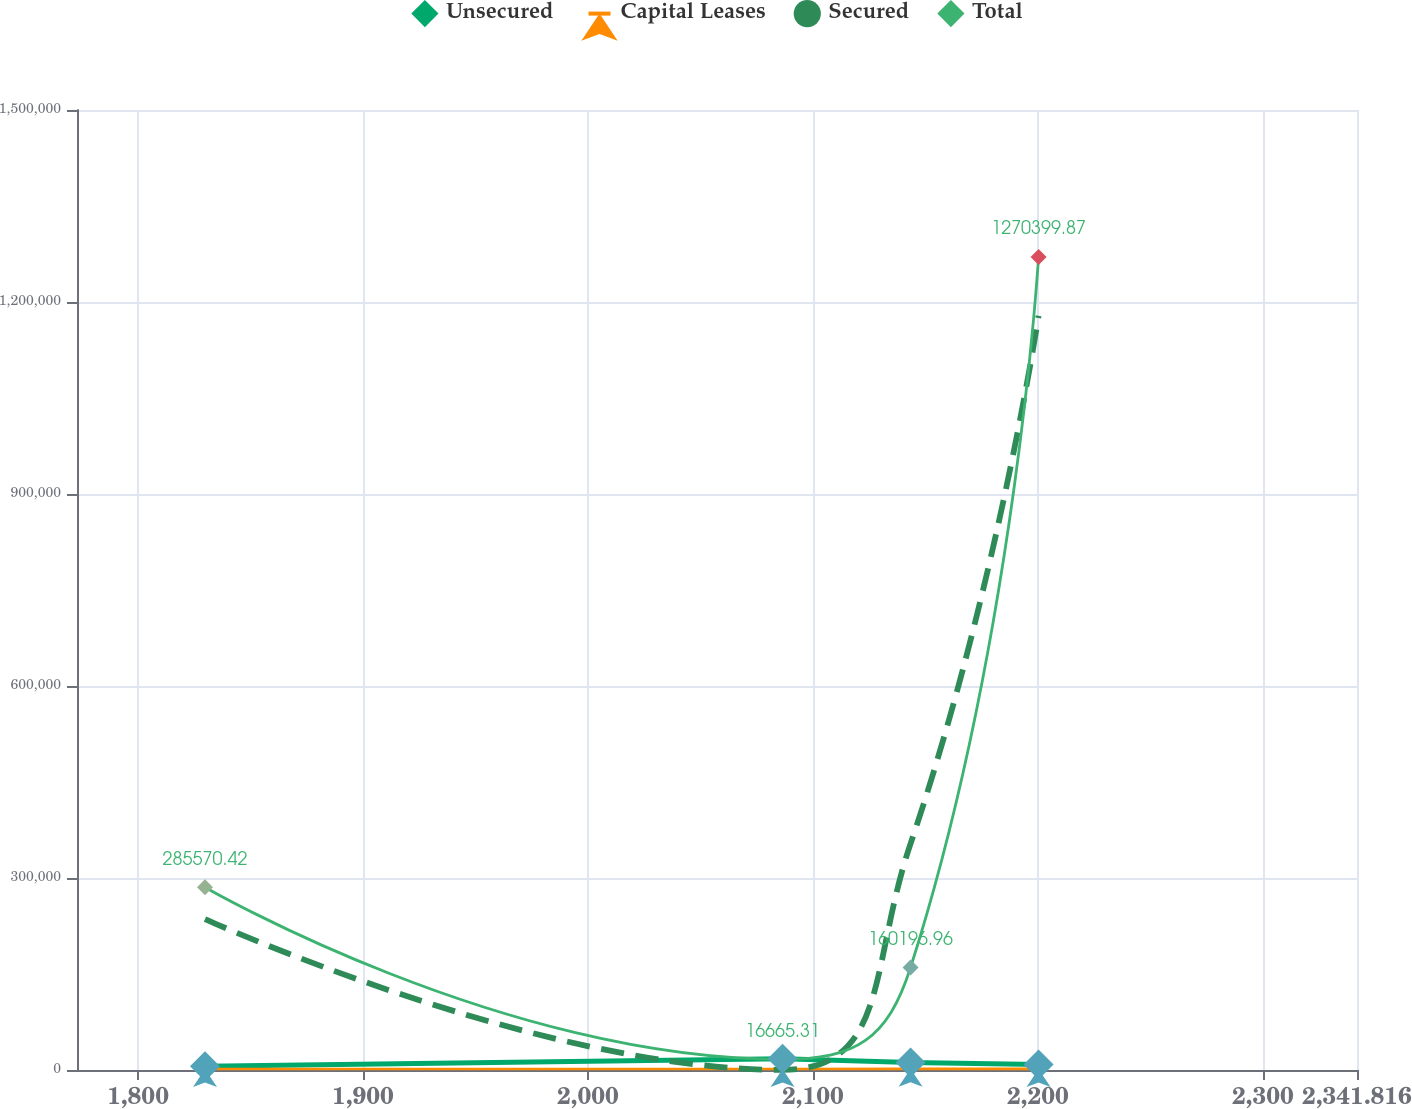<chart> <loc_0><loc_0><loc_500><loc_500><line_chart><ecel><fcel>Unsecured<fcel>Capital Leases<fcel>Secured<fcel>Total<nl><fcel>1829.77<fcel>5705.26<fcel>1502.6<fcel>235867<fcel>285570<nl><fcel>2086.49<fcel>17407.8<fcel>1572.05<fcel>201.38<fcel>16665.3<nl><fcel>2143.38<fcel>11636.7<fcel>1820.85<fcel>353699<fcel>160197<nl><fcel>2200.27<fcel>8670.97<fcel>1751.4<fcel>1.17853e+06<fcel>1.2704e+06<nl><fcel>2398.71<fcel>35362.4<fcel>2197.12<fcel>118034<fcel>1.06164e+06<nl></chart> 